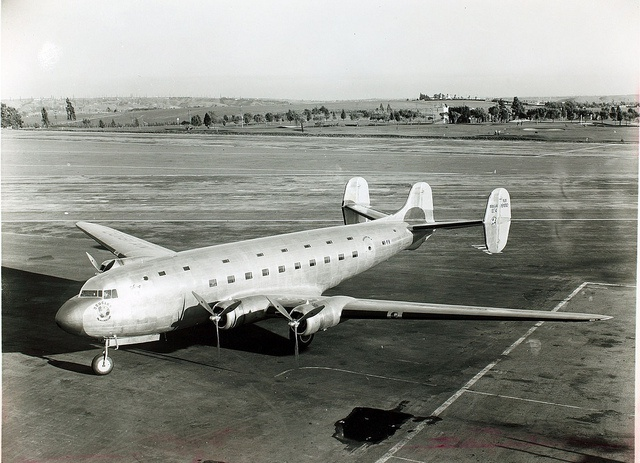Describe the objects in this image and their specific colors. I can see a airplane in white, lightgray, darkgray, black, and gray tones in this image. 